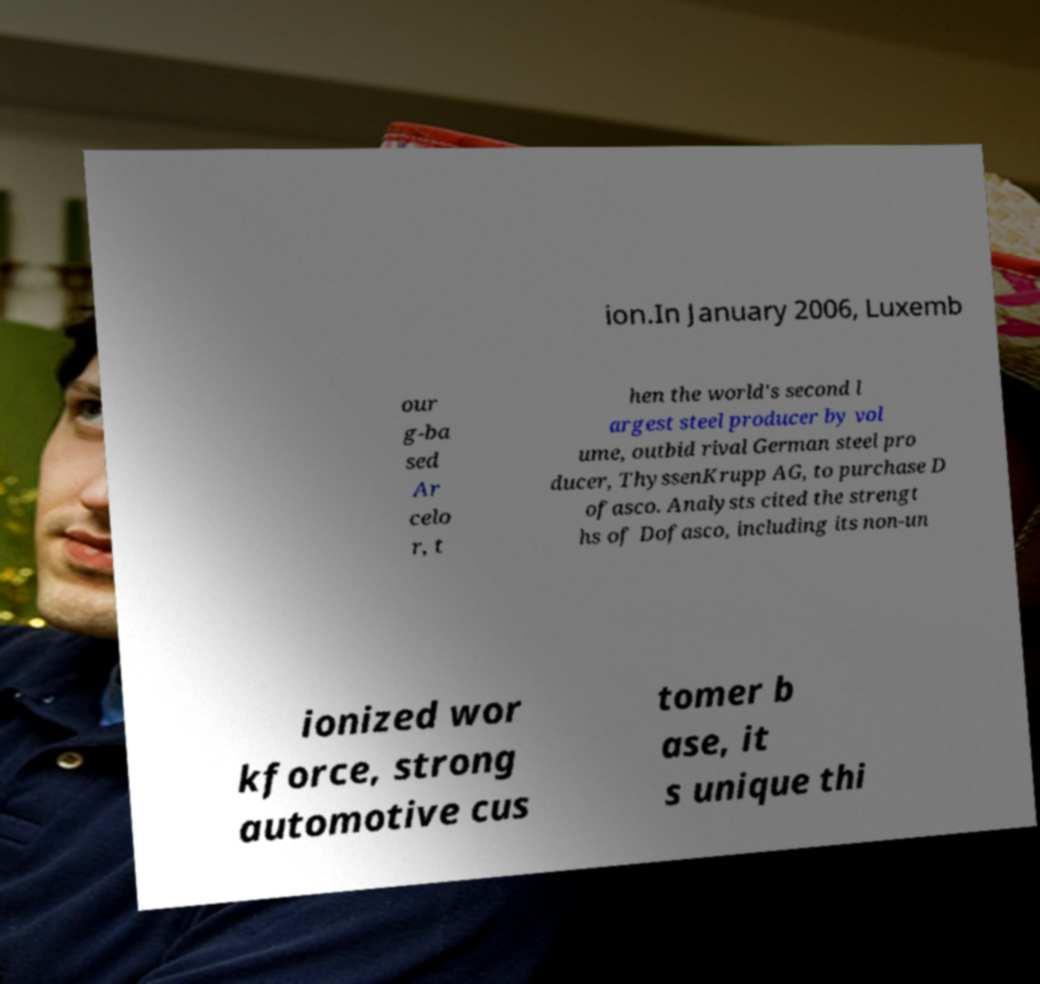Can you accurately transcribe the text from the provided image for me? ion.In January 2006, Luxemb our g-ba sed Ar celo r, t hen the world's second l argest steel producer by vol ume, outbid rival German steel pro ducer, ThyssenKrupp AG, to purchase D ofasco. Analysts cited the strengt hs of Dofasco, including its non-un ionized wor kforce, strong automotive cus tomer b ase, it s unique thi 